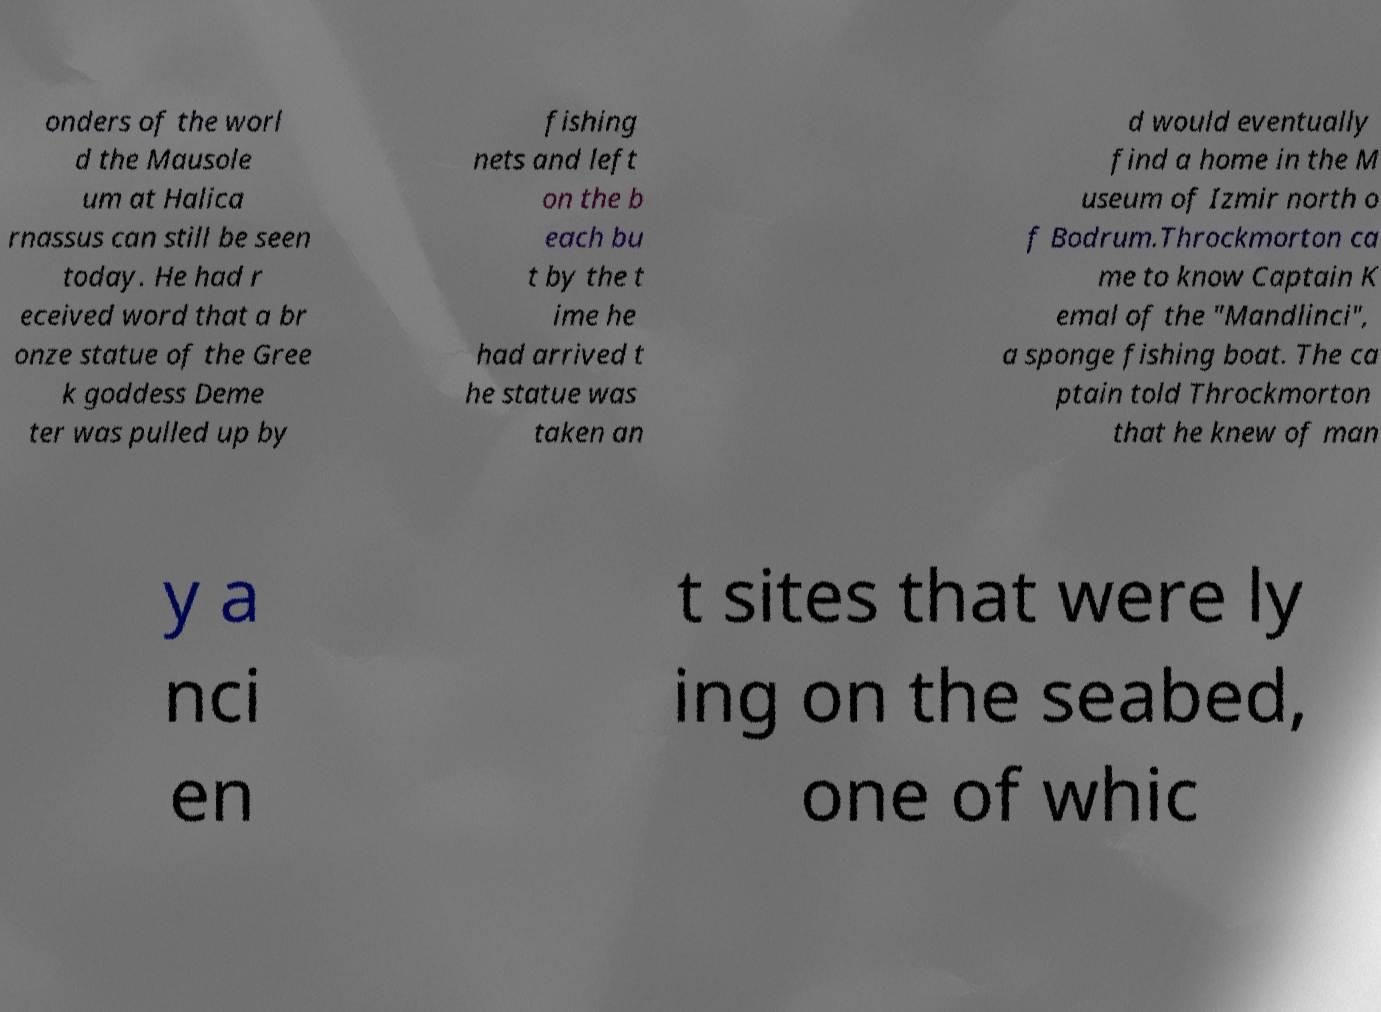Can you accurately transcribe the text from the provided image for me? onders of the worl d the Mausole um at Halica rnassus can still be seen today. He had r eceived word that a br onze statue of the Gree k goddess Deme ter was pulled up by fishing nets and left on the b each bu t by the t ime he had arrived t he statue was taken an d would eventually find a home in the M useum of Izmir north o f Bodrum.Throckmorton ca me to know Captain K emal of the "Mandlinci", a sponge fishing boat. The ca ptain told Throckmorton that he knew of man y a nci en t sites that were ly ing on the seabed, one of whic 